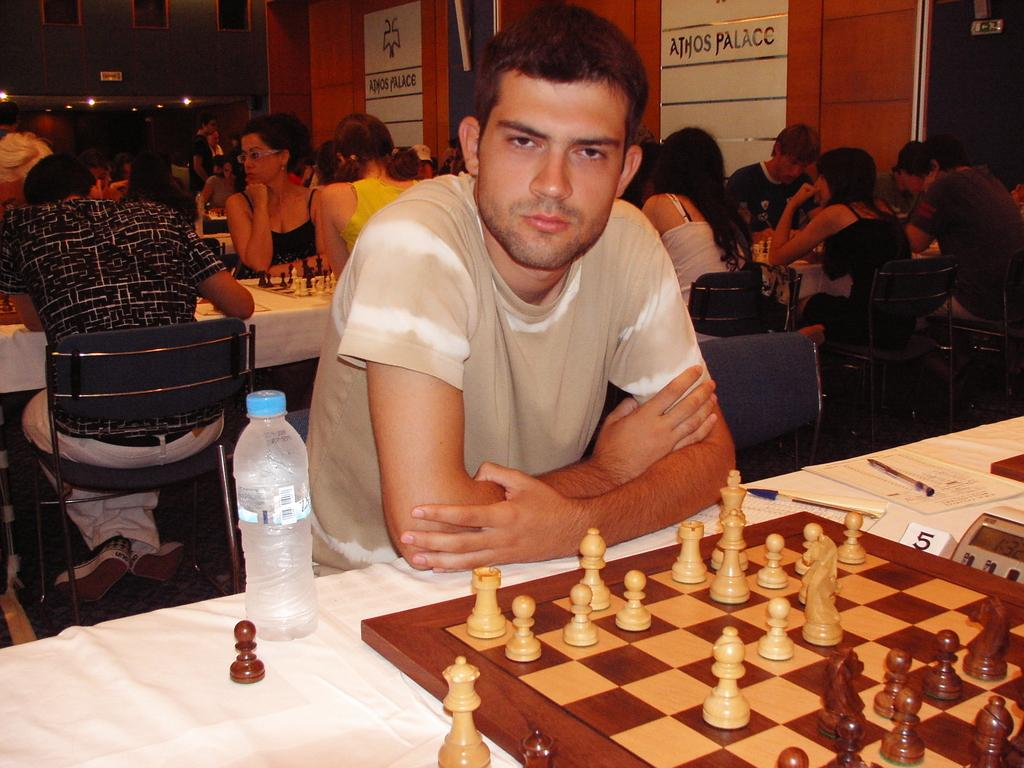What are the people in the image doing? The people in the image are sitting on chairs. What is present on the table in the image? There is a bottle and a chess board on the table. Can you describe the table in the image? The table is a flat surface with objects on it, including a bottle and a chess board. What type of turkey is being served on the chess board in the image? There is no turkey present in the image; the table has a chess board and a bottle on it. How many people are sleeping in the image? There are no people sleeping in the image; the people are sitting on chairs. 